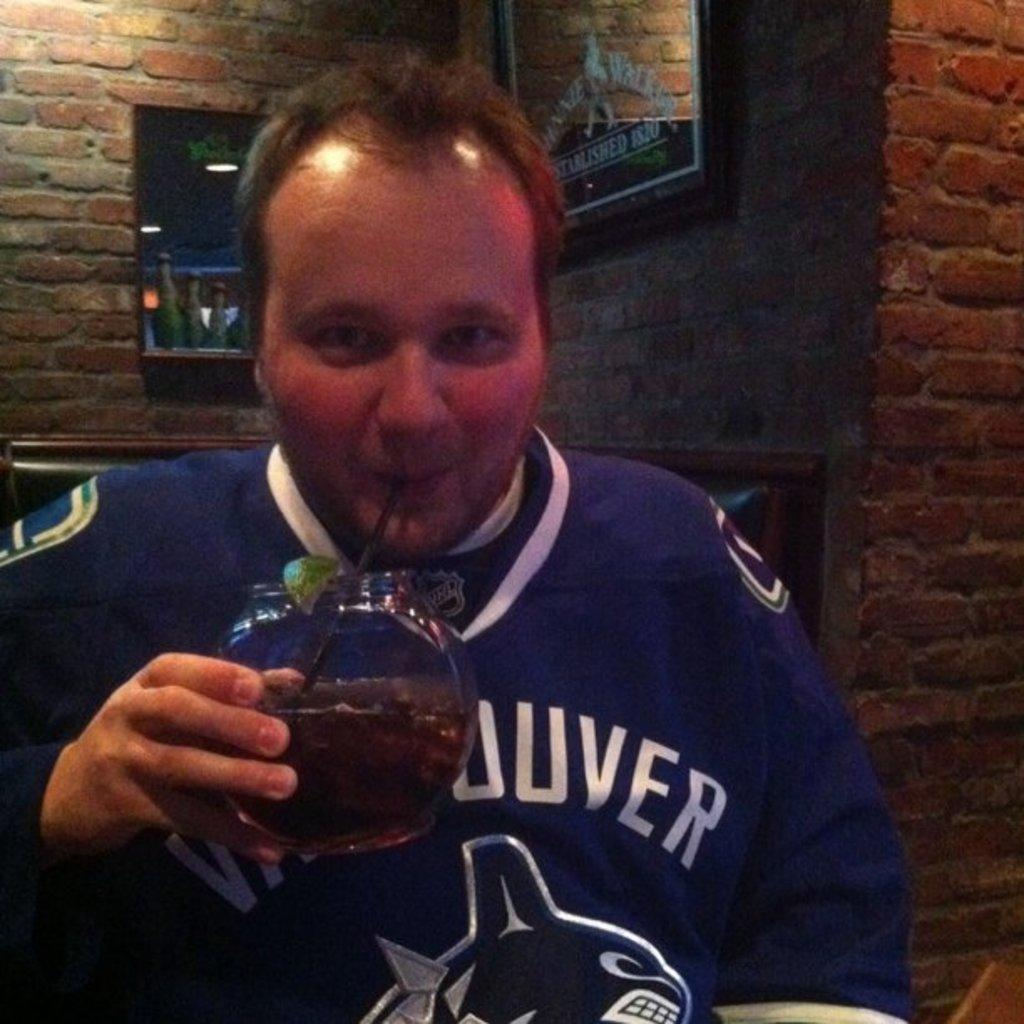Who is present in the image? There is a man in the image. What is the man holding in the image? The man is holding a glass. How is the man drinking from the glass? The man is drinking with the help of a straw. What can be seen in the background of the image? There are lights and a frame on the wall visible in the background of the image. What type of fuel is being used by the man in the image? There is no fuel present in the image; the man is drinking from a glass with the help of a straw. What shape is the man's lip in the image? The image does not show the shape of the man's lip, as it focuses on the man holding a glass and drinking with a straw. 